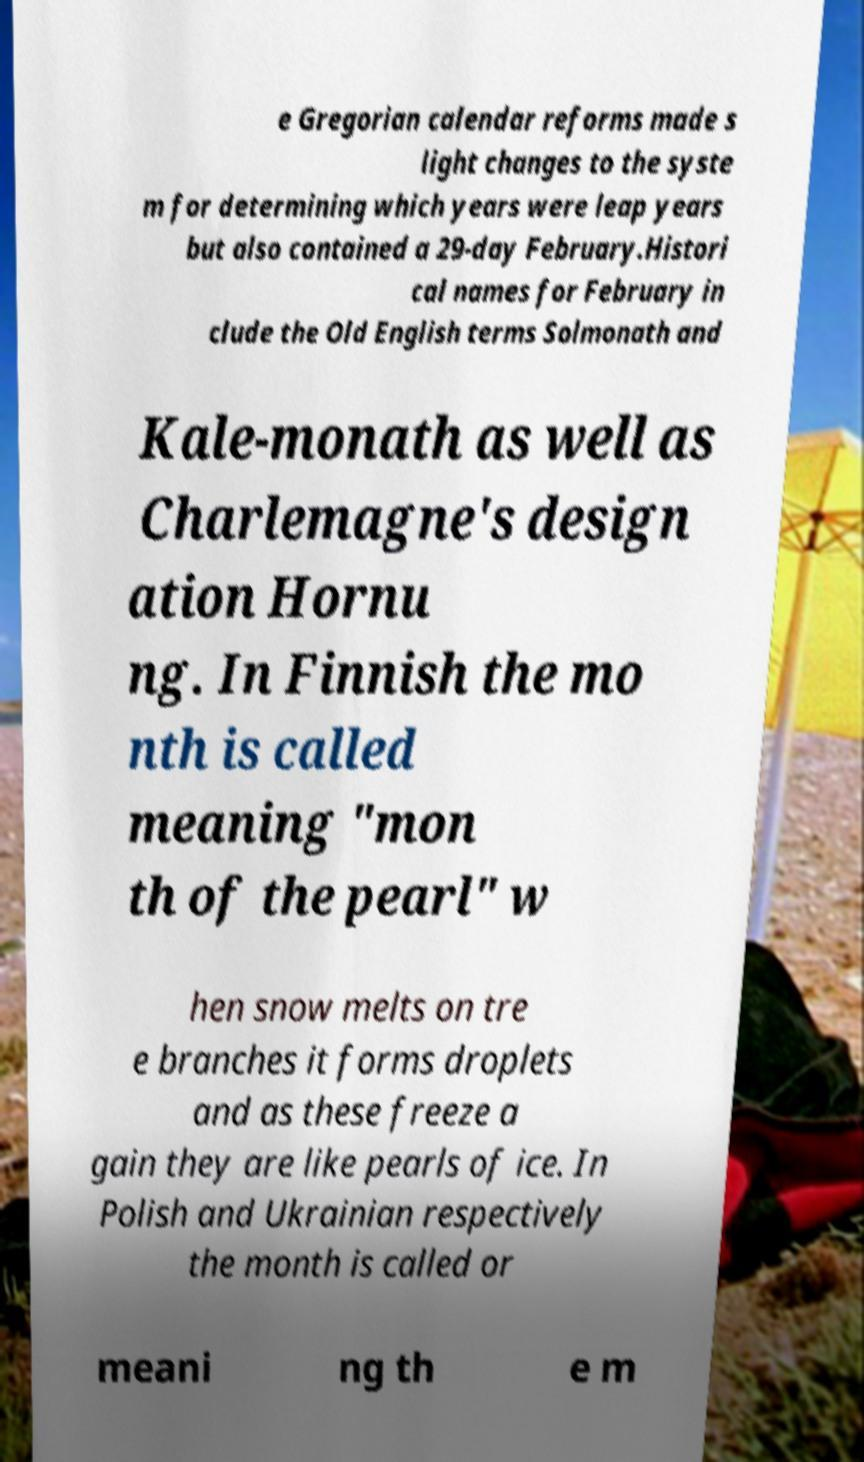Can you accurately transcribe the text from the provided image for me? e Gregorian calendar reforms made s light changes to the syste m for determining which years were leap years but also contained a 29-day February.Histori cal names for February in clude the Old English terms Solmonath and Kale-monath as well as Charlemagne's design ation Hornu ng. In Finnish the mo nth is called meaning "mon th of the pearl" w hen snow melts on tre e branches it forms droplets and as these freeze a gain they are like pearls of ice. In Polish and Ukrainian respectively the month is called or meani ng th e m 